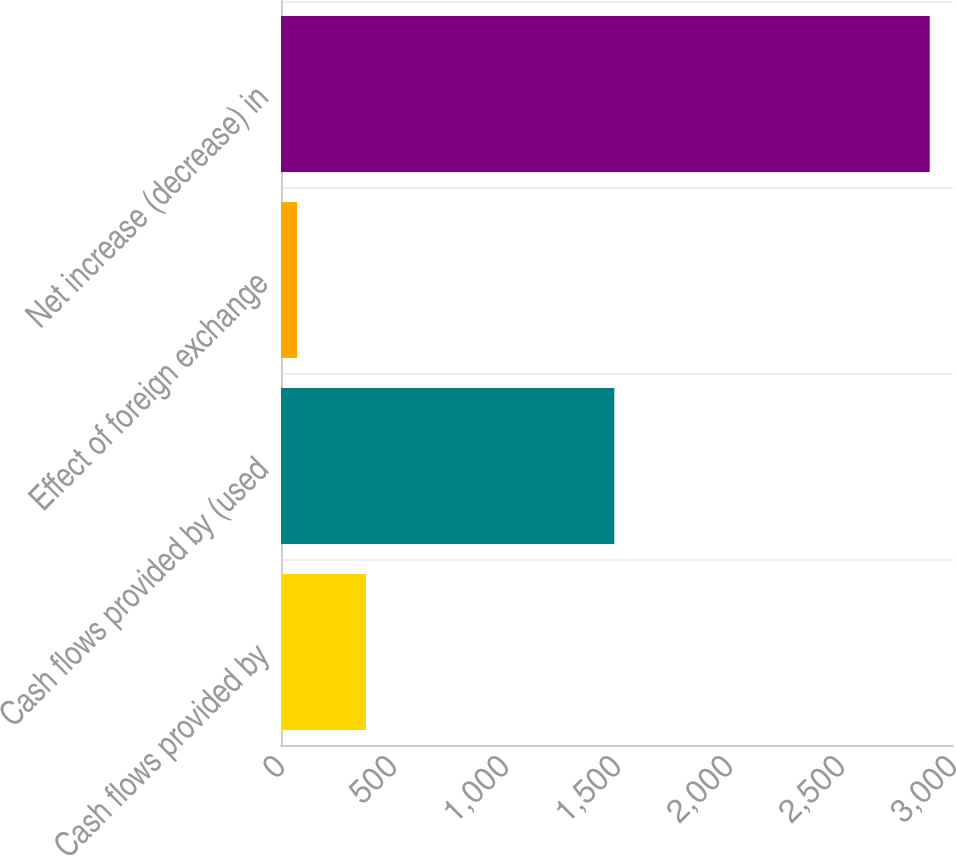<chart> <loc_0><loc_0><loc_500><loc_500><bar_chart><fcel>Cash flows provided by<fcel>Cash flows provided by (used<fcel>Effect of foreign exchange<fcel>Net increase (decrease) in<nl><fcel>379<fcel>1488<fcel>72<fcel>2896<nl></chart> 